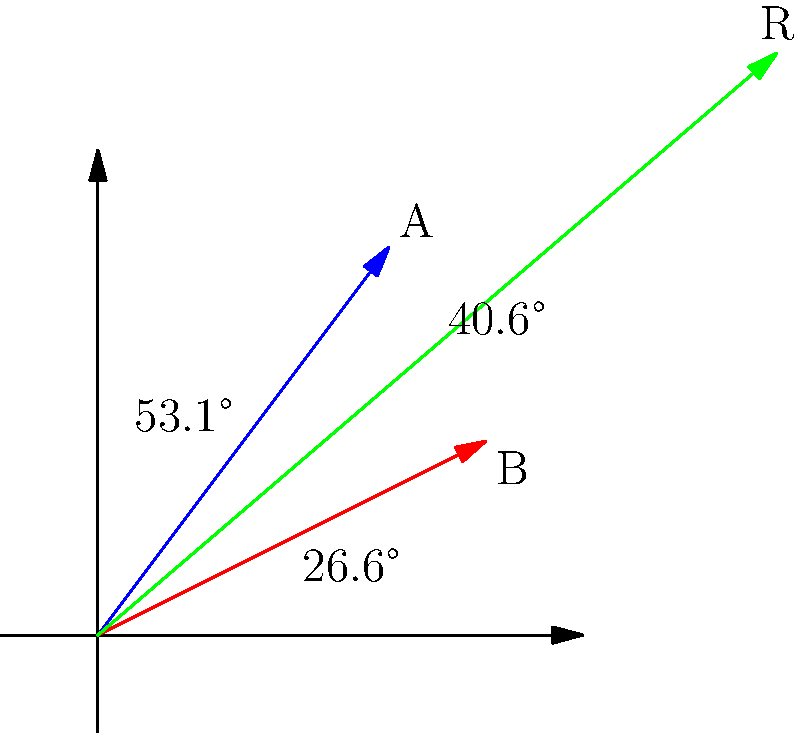In the vector diagram above, vectors A and B represent the growth directions of two branches from a plant stem. Vector A has a magnitude of 5 units and forms an angle of 53.1° with the horizontal, while vector B has a magnitude of 4.47 units and forms an angle of 26.6° with the horizontal. What is the magnitude of the resultant vector R, which represents the overall growth direction of the plant? To find the magnitude of the resultant vector R, we need to follow these steps:

1. Convert the given polar coordinates (magnitude and angle) to rectangular coordinates:
   Vector A: $A_x = 5 \cos(53.1°) = 3$, $A_y = 5 \sin(53.1°) = 4$
   Vector B: $B_x = 4.47 \cos(26.6°) = 4$, $B_y = 4.47 \sin(26.6°) = 2$

2. Add the x and y components of vectors A and B to get the components of vector R:
   $R_x = A_x + B_x = 3 + 4 = 7$
   $R_y = A_y + B_y = 4 + 2 = 6$

3. Calculate the magnitude of vector R using the Pythagorean theorem:
   $|R| = \sqrt{R_x^2 + R_y^2} = \sqrt{7^2 + 6^2} = \sqrt{49 + 36} = \sqrt{85}$

4. Simplify the result:
   $|R| = \sqrt{85} \approx 9.22$ units

Therefore, the magnitude of the resultant vector R is approximately 9.22 units.
Answer: 9.22 units 